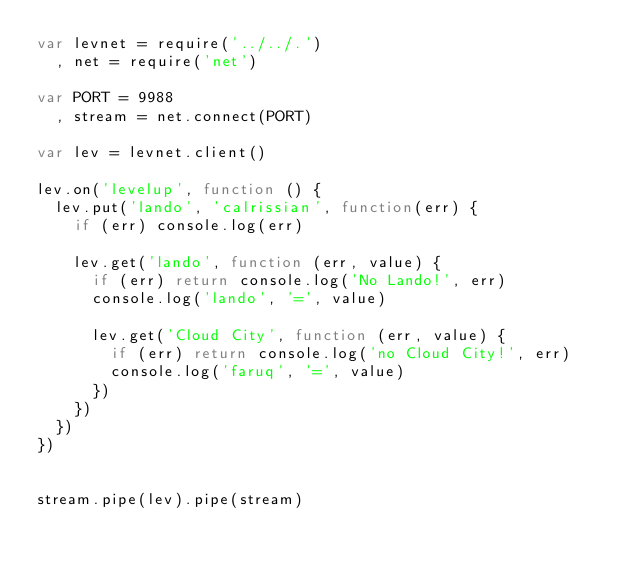<code> <loc_0><loc_0><loc_500><loc_500><_JavaScript_>var levnet = require('../../.')
  , net = require('net')

var PORT = 9988
  , stream = net.connect(PORT)

var lev = levnet.client()

lev.on('levelup', function () {
  lev.put('lando', 'calrissian', function(err) {
    if (err) console.log(err)

    lev.get('lando', function (err, value) {
      if (err) return console.log('No Lando!', err)
      console.log('lando', '=', value)

      lev.get('Cloud City', function (err, value) {
        if (err) return console.log('no Cloud City!', err)
        console.log('faruq', '=', value)
      })
    })
  })
})


stream.pipe(lev).pipe(stream)

</code> 